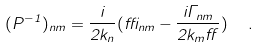<formula> <loc_0><loc_0><loc_500><loc_500>( P ^ { - 1 } ) _ { n m } = \frac { i } { 2 k _ { n } } ( \delta _ { n m } - \frac { i \Gamma _ { n m } } { 2 k _ { m } \alpha } ) \ \ .</formula> 